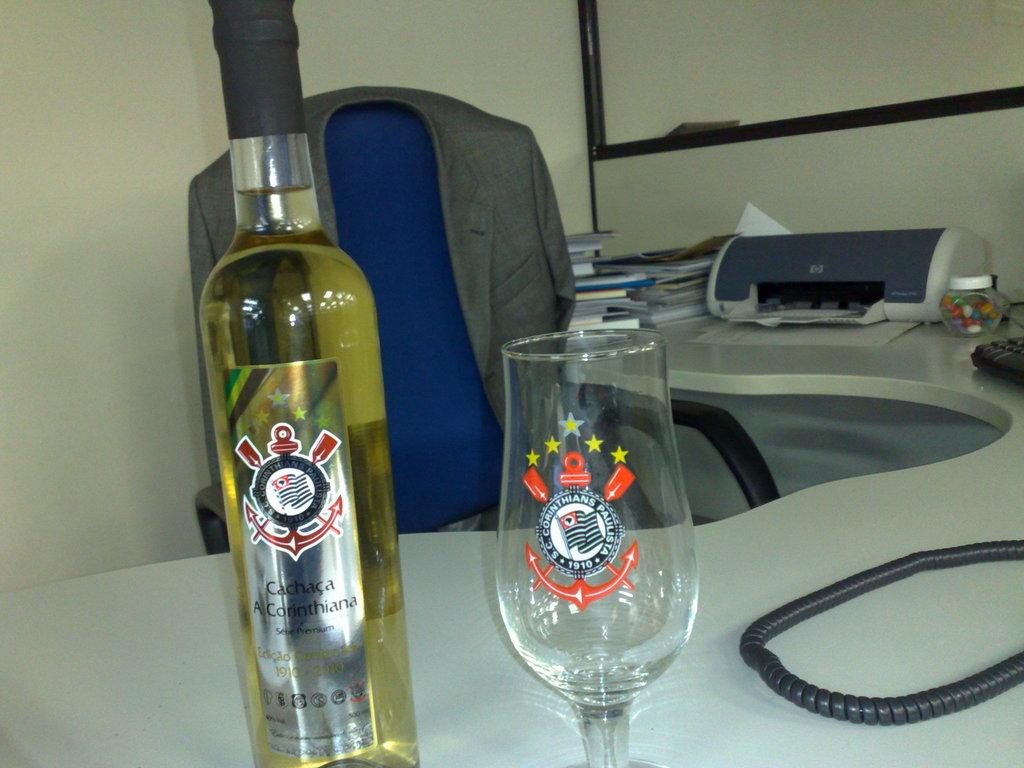<image>
Provide a brief description of the given image. A bottle of white wine and a glass which says Cachaca A Corinthiana. 